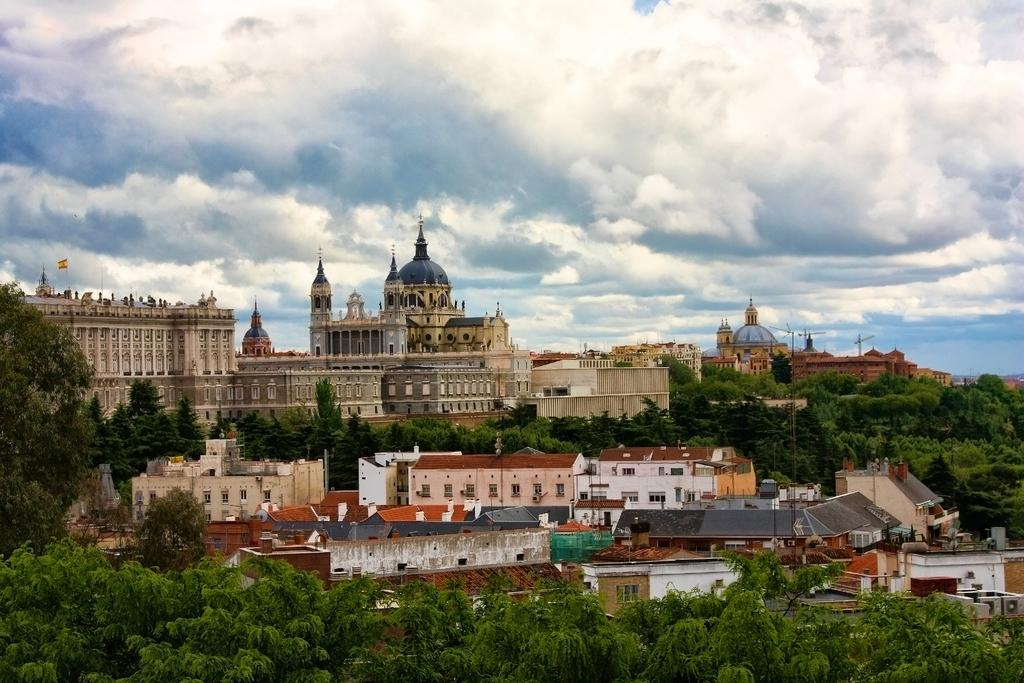What type of view is shown in the image? The image is an aerial view of a city. What can be seen in the foreground of the image? There are trees and buildings in the foreground of the image. What is the condition of the sky in the image? The sky is cloudy in the image. What type of whip can be seen in the image? There is no whip present in the image. What record is being played in the image? There is no record or music player visible in the image. 